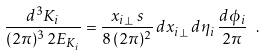Convert formula to latex. <formula><loc_0><loc_0><loc_500><loc_500>\frac { d ^ { 3 } K _ { i } } { ( 2 \pi ) ^ { 3 } \, 2 E _ { K _ { i } } } = \frac { x _ { i \perp } \, s } { 8 \, ( 2 \pi ) ^ { 2 } } \, d x _ { i \perp } \, d \eta _ { i } \, \frac { d \phi _ { i } } { 2 \pi } \ .</formula> 